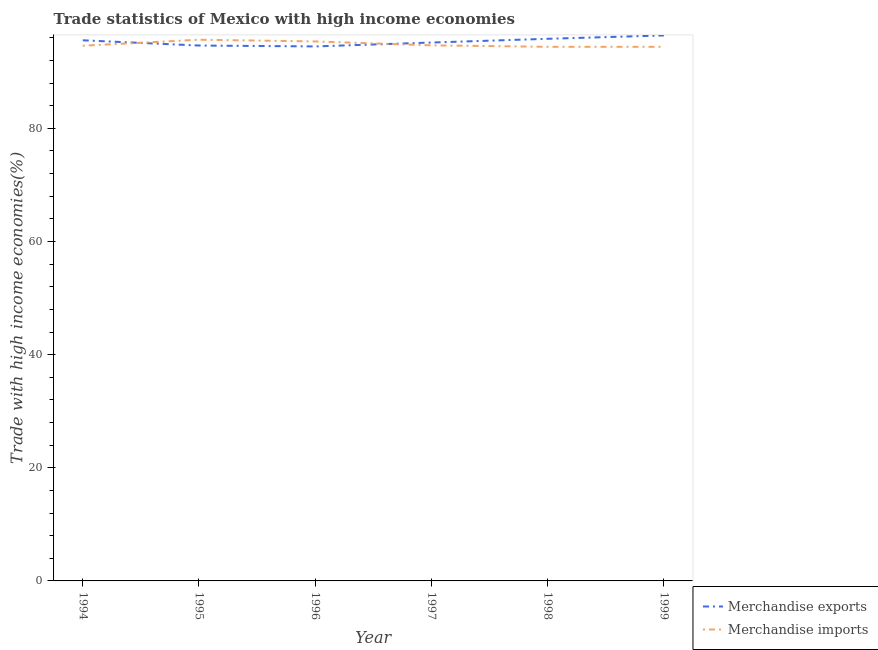Does the line corresponding to merchandise exports intersect with the line corresponding to merchandise imports?
Provide a succinct answer. Yes. What is the merchandise imports in 1995?
Give a very brief answer. 95.66. Across all years, what is the maximum merchandise exports?
Offer a terse response. 96.42. Across all years, what is the minimum merchandise exports?
Your response must be concise. 94.48. What is the total merchandise imports in the graph?
Ensure brevity in your answer.  569.12. What is the difference between the merchandise exports in 1994 and that in 1996?
Offer a terse response. 1.09. What is the difference between the merchandise imports in 1994 and the merchandise exports in 1995?
Provide a succinct answer. -0.04. What is the average merchandise imports per year?
Provide a succinct answer. 94.85. In the year 1997, what is the difference between the merchandise imports and merchandise exports?
Provide a short and direct response. -0.5. What is the ratio of the merchandise exports in 1994 to that in 1997?
Offer a very short reply. 1. Is the merchandise exports in 1995 less than that in 1999?
Your response must be concise. Yes. Is the difference between the merchandise exports in 1997 and 1999 greater than the difference between the merchandise imports in 1997 and 1999?
Provide a succinct answer. No. What is the difference between the highest and the second highest merchandise imports?
Offer a terse response. 0.3. What is the difference between the highest and the lowest merchandise imports?
Offer a very short reply. 1.25. In how many years, is the merchandise imports greater than the average merchandise imports taken over all years?
Provide a succinct answer. 2. Does the merchandise imports monotonically increase over the years?
Offer a very short reply. No. Is the merchandise exports strictly greater than the merchandise imports over the years?
Make the answer very short. No. Is the merchandise imports strictly less than the merchandise exports over the years?
Provide a succinct answer. No. How many years are there in the graph?
Provide a succinct answer. 6. Does the graph contain any zero values?
Provide a short and direct response. No. Where does the legend appear in the graph?
Offer a very short reply. Bottom right. How many legend labels are there?
Provide a succinct answer. 2. How are the legend labels stacked?
Keep it short and to the point. Vertical. What is the title of the graph?
Make the answer very short. Trade statistics of Mexico with high income economies. What is the label or title of the X-axis?
Offer a terse response. Year. What is the label or title of the Y-axis?
Give a very brief answer. Trade with high income economies(%). What is the Trade with high income economies(%) of Merchandise exports in 1994?
Your answer should be very brief. 95.56. What is the Trade with high income economies(%) of Merchandise imports in 1994?
Give a very brief answer. 94.6. What is the Trade with high income economies(%) of Merchandise exports in 1995?
Your answer should be very brief. 94.64. What is the Trade with high income economies(%) of Merchandise imports in 1995?
Ensure brevity in your answer.  95.66. What is the Trade with high income economies(%) in Merchandise exports in 1996?
Keep it short and to the point. 94.48. What is the Trade with high income economies(%) of Merchandise imports in 1996?
Keep it short and to the point. 95.36. What is the Trade with high income economies(%) of Merchandise exports in 1997?
Ensure brevity in your answer.  95.17. What is the Trade with high income economies(%) of Merchandise imports in 1997?
Your answer should be compact. 94.67. What is the Trade with high income economies(%) in Merchandise exports in 1998?
Provide a succinct answer. 95.83. What is the Trade with high income economies(%) in Merchandise imports in 1998?
Ensure brevity in your answer.  94.41. What is the Trade with high income economies(%) in Merchandise exports in 1999?
Your answer should be compact. 96.42. What is the Trade with high income economies(%) of Merchandise imports in 1999?
Ensure brevity in your answer.  94.41. Across all years, what is the maximum Trade with high income economies(%) in Merchandise exports?
Keep it short and to the point. 96.42. Across all years, what is the maximum Trade with high income economies(%) in Merchandise imports?
Make the answer very short. 95.66. Across all years, what is the minimum Trade with high income economies(%) in Merchandise exports?
Offer a terse response. 94.48. Across all years, what is the minimum Trade with high income economies(%) in Merchandise imports?
Offer a terse response. 94.41. What is the total Trade with high income economies(%) of Merchandise exports in the graph?
Offer a very short reply. 572.1. What is the total Trade with high income economies(%) in Merchandise imports in the graph?
Provide a succinct answer. 569.12. What is the difference between the Trade with high income economies(%) in Merchandise exports in 1994 and that in 1995?
Give a very brief answer. 0.93. What is the difference between the Trade with high income economies(%) of Merchandise imports in 1994 and that in 1995?
Ensure brevity in your answer.  -1.06. What is the difference between the Trade with high income economies(%) in Merchandise exports in 1994 and that in 1996?
Ensure brevity in your answer.  1.08. What is the difference between the Trade with high income economies(%) in Merchandise imports in 1994 and that in 1996?
Your answer should be very brief. -0.76. What is the difference between the Trade with high income economies(%) in Merchandise exports in 1994 and that in 1997?
Ensure brevity in your answer.  0.4. What is the difference between the Trade with high income economies(%) of Merchandise imports in 1994 and that in 1997?
Your response must be concise. -0.07. What is the difference between the Trade with high income economies(%) in Merchandise exports in 1994 and that in 1998?
Your answer should be compact. -0.26. What is the difference between the Trade with high income economies(%) of Merchandise imports in 1994 and that in 1998?
Your response must be concise. 0.19. What is the difference between the Trade with high income economies(%) in Merchandise exports in 1994 and that in 1999?
Keep it short and to the point. -0.86. What is the difference between the Trade with high income economies(%) of Merchandise imports in 1994 and that in 1999?
Offer a very short reply. 0.19. What is the difference between the Trade with high income economies(%) of Merchandise exports in 1995 and that in 1996?
Your response must be concise. 0.16. What is the difference between the Trade with high income economies(%) of Merchandise imports in 1995 and that in 1996?
Provide a succinct answer. 0.3. What is the difference between the Trade with high income economies(%) in Merchandise exports in 1995 and that in 1997?
Offer a very short reply. -0.53. What is the difference between the Trade with high income economies(%) of Merchandise imports in 1995 and that in 1997?
Keep it short and to the point. 0.99. What is the difference between the Trade with high income economies(%) of Merchandise exports in 1995 and that in 1998?
Make the answer very short. -1.19. What is the difference between the Trade with high income economies(%) of Merchandise imports in 1995 and that in 1998?
Make the answer very short. 1.25. What is the difference between the Trade with high income economies(%) in Merchandise exports in 1995 and that in 1999?
Give a very brief answer. -1.78. What is the difference between the Trade with high income economies(%) of Merchandise imports in 1995 and that in 1999?
Your response must be concise. 1.25. What is the difference between the Trade with high income economies(%) in Merchandise exports in 1996 and that in 1997?
Your answer should be compact. -0.69. What is the difference between the Trade with high income economies(%) of Merchandise imports in 1996 and that in 1997?
Provide a succinct answer. 0.69. What is the difference between the Trade with high income economies(%) of Merchandise exports in 1996 and that in 1998?
Make the answer very short. -1.35. What is the difference between the Trade with high income economies(%) of Merchandise imports in 1996 and that in 1998?
Offer a terse response. 0.95. What is the difference between the Trade with high income economies(%) in Merchandise exports in 1996 and that in 1999?
Your response must be concise. -1.94. What is the difference between the Trade with high income economies(%) of Merchandise imports in 1996 and that in 1999?
Offer a terse response. 0.95. What is the difference between the Trade with high income economies(%) in Merchandise exports in 1997 and that in 1998?
Your response must be concise. -0.66. What is the difference between the Trade with high income economies(%) of Merchandise imports in 1997 and that in 1998?
Your response must be concise. 0.26. What is the difference between the Trade with high income economies(%) in Merchandise exports in 1997 and that in 1999?
Your answer should be compact. -1.25. What is the difference between the Trade with high income economies(%) in Merchandise imports in 1997 and that in 1999?
Make the answer very short. 0.26. What is the difference between the Trade with high income economies(%) in Merchandise exports in 1998 and that in 1999?
Make the answer very short. -0.59. What is the difference between the Trade with high income economies(%) of Merchandise imports in 1998 and that in 1999?
Offer a terse response. -0. What is the difference between the Trade with high income economies(%) of Merchandise exports in 1994 and the Trade with high income economies(%) of Merchandise imports in 1995?
Ensure brevity in your answer.  -0.1. What is the difference between the Trade with high income economies(%) of Merchandise exports in 1994 and the Trade with high income economies(%) of Merchandise imports in 1996?
Your answer should be very brief. 0.2. What is the difference between the Trade with high income economies(%) in Merchandise exports in 1994 and the Trade with high income economies(%) in Merchandise imports in 1997?
Make the answer very short. 0.89. What is the difference between the Trade with high income economies(%) in Merchandise exports in 1994 and the Trade with high income economies(%) in Merchandise imports in 1998?
Ensure brevity in your answer.  1.15. What is the difference between the Trade with high income economies(%) in Merchandise exports in 1994 and the Trade with high income economies(%) in Merchandise imports in 1999?
Offer a terse response. 1.15. What is the difference between the Trade with high income economies(%) of Merchandise exports in 1995 and the Trade with high income economies(%) of Merchandise imports in 1996?
Your answer should be compact. -0.72. What is the difference between the Trade with high income economies(%) of Merchandise exports in 1995 and the Trade with high income economies(%) of Merchandise imports in 1997?
Make the answer very short. -0.03. What is the difference between the Trade with high income economies(%) of Merchandise exports in 1995 and the Trade with high income economies(%) of Merchandise imports in 1998?
Provide a short and direct response. 0.23. What is the difference between the Trade with high income economies(%) in Merchandise exports in 1995 and the Trade with high income economies(%) in Merchandise imports in 1999?
Your answer should be very brief. 0.22. What is the difference between the Trade with high income economies(%) of Merchandise exports in 1996 and the Trade with high income economies(%) of Merchandise imports in 1997?
Keep it short and to the point. -0.19. What is the difference between the Trade with high income economies(%) in Merchandise exports in 1996 and the Trade with high income economies(%) in Merchandise imports in 1998?
Make the answer very short. 0.07. What is the difference between the Trade with high income economies(%) in Merchandise exports in 1996 and the Trade with high income economies(%) in Merchandise imports in 1999?
Your answer should be very brief. 0.07. What is the difference between the Trade with high income economies(%) in Merchandise exports in 1997 and the Trade with high income economies(%) in Merchandise imports in 1998?
Provide a succinct answer. 0.76. What is the difference between the Trade with high income economies(%) of Merchandise exports in 1997 and the Trade with high income economies(%) of Merchandise imports in 1999?
Provide a short and direct response. 0.75. What is the difference between the Trade with high income economies(%) of Merchandise exports in 1998 and the Trade with high income economies(%) of Merchandise imports in 1999?
Offer a terse response. 1.42. What is the average Trade with high income economies(%) in Merchandise exports per year?
Provide a short and direct response. 95.35. What is the average Trade with high income economies(%) in Merchandise imports per year?
Offer a terse response. 94.85. In the year 1994, what is the difference between the Trade with high income economies(%) of Merchandise exports and Trade with high income economies(%) of Merchandise imports?
Give a very brief answer. 0.96. In the year 1995, what is the difference between the Trade with high income economies(%) in Merchandise exports and Trade with high income economies(%) in Merchandise imports?
Your answer should be very brief. -1.03. In the year 1996, what is the difference between the Trade with high income economies(%) of Merchandise exports and Trade with high income economies(%) of Merchandise imports?
Offer a terse response. -0.88. In the year 1997, what is the difference between the Trade with high income economies(%) in Merchandise exports and Trade with high income economies(%) in Merchandise imports?
Offer a very short reply. 0.5. In the year 1998, what is the difference between the Trade with high income economies(%) in Merchandise exports and Trade with high income economies(%) in Merchandise imports?
Offer a terse response. 1.42. In the year 1999, what is the difference between the Trade with high income economies(%) in Merchandise exports and Trade with high income economies(%) in Merchandise imports?
Give a very brief answer. 2.01. What is the ratio of the Trade with high income economies(%) of Merchandise exports in 1994 to that in 1995?
Your response must be concise. 1.01. What is the ratio of the Trade with high income economies(%) in Merchandise imports in 1994 to that in 1995?
Keep it short and to the point. 0.99. What is the ratio of the Trade with high income economies(%) of Merchandise exports in 1994 to that in 1996?
Keep it short and to the point. 1.01. What is the ratio of the Trade with high income economies(%) of Merchandise imports in 1994 to that in 1996?
Make the answer very short. 0.99. What is the ratio of the Trade with high income economies(%) in Merchandise imports in 1994 to that in 1997?
Provide a short and direct response. 1. What is the ratio of the Trade with high income economies(%) of Merchandise exports in 1994 to that in 1998?
Give a very brief answer. 1. What is the ratio of the Trade with high income economies(%) in Merchandise exports in 1994 to that in 1999?
Keep it short and to the point. 0.99. What is the ratio of the Trade with high income economies(%) in Merchandise imports in 1994 to that in 1999?
Keep it short and to the point. 1. What is the ratio of the Trade with high income economies(%) of Merchandise exports in 1995 to that in 1996?
Your answer should be very brief. 1. What is the ratio of the Trade with high income economies(%) in Merchandise imports in 1995 to that in 1996?
Your answer should be very brief. 1. What is the ratio of the Trade with high income economies(%) in Merchandise exports in 1995 to that in 1997?
Your response must be concise. 0.99. What is the ratio of the Trade with high income economies(%) in Merchandise imports in 1995 to that in 1997?
Provide a succinct answer. 1.01. What is the ratio of the Trade with high income economies(%) in Merchandise exports in 1995 to that in 1998?
Your answer should be very brief. 0.99. What is the ratio of the Trade with high income economies(%) of Merchandise imports in 1995 to that in 1998?
Provide a succinct answer. 1.01. What is the ratio of the Trade with high income economies(%) of Merchandise exports in 1995 to that in 1999?
Provide a short and direct response. 0.98. What is the ratio of the Trade with high income economies(%) of Merchandise imports in 1995 to that in 1999?
Provide a short and direct response. 1.01. What is the ratio of the Trade with high income economies(%) in Merchandise exports in 1996 to that in 1997?
Your response must be concise. 0.99. What is the ratio of the Trade with high income economies(%) in Merchandise imports in 1996 to that in 1997?
Keep it short and to the point. 1.01. What is the ratio of the Trade with high income economies(%) of Merchandise exports in 1996 to that in 1998?
Make the answer very short. 0.99. What is the ratio of the Trade with high income economies(%) of Merchandise imports in 1996 to that in 1998?
Offer a very short reply. 1.01. What is the ratio of the Trade with high income economies(%) in Merchandise exports in 1996 to that in 1999?
Offer a terse response. 0.98. What is the ratio of the Trade with high income economies(%) in Merchandise exports in 1998 to that in 1999?
Make the answer very short. 0.99. What is the difference between the highest and the second highest Trade with high income economies(%) in Merchandise exports?
Your answer should be very brief. 0.59. What is the difference between the highest and the second highest Trade with high income economies(%) in Merchandise imports?
Ensure brevity in your answer.  0.3. What is the difference between the highest and the lowest Trade with high income economies(%) of Merchandise exports?
Provide a succinct answer. 1.94. What is the difference between the highest and the lowest Trade with high income economies(%) in Merchandise imports?
Ensure brevity in your answer.  1.25. 